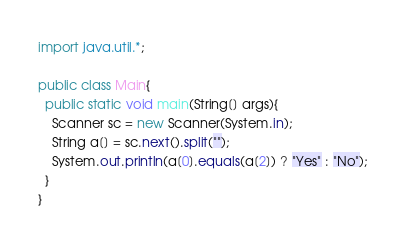<code> <loc_0><loc_0><loc_500><loc_500><_Java_>import java.util.*;

public class Main{
  public static void main(String[] args){
    Scanner sc = new Scanner(System.in);
    String a[] = sc.next().split("");
    System.out.println(a[0].equals(a[2]) ? "Yes" : "No");
  }
}
</code> 